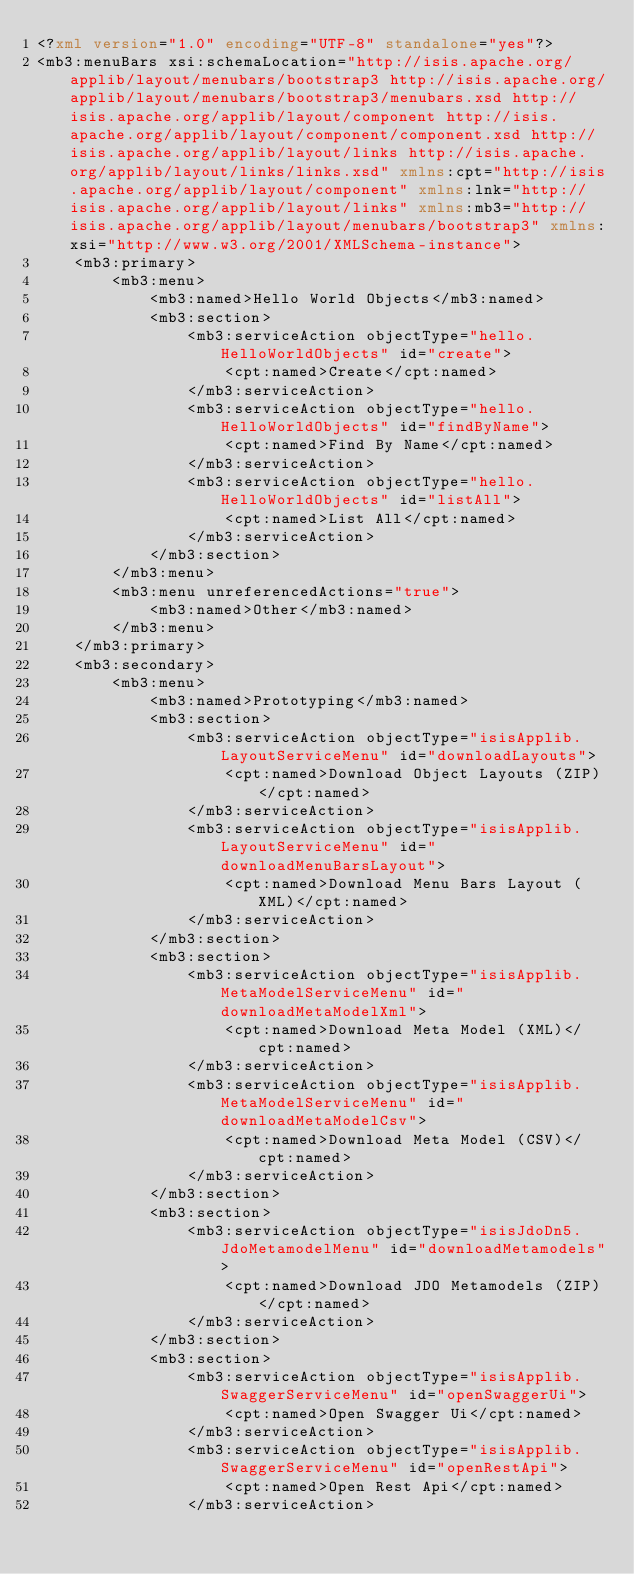<code> <loc_0><loc_0><loc_500><loc_500><_XML_><?xml version="1.0" encoding="UTF-8" standalone="yes"?>
<mb3:menuBars xsi:schemaLocation="http://isis.apache.org/applib/layout/menubars/bootstrap3 http://isis.apache.org/applib/layout/menubars/bootstrap3/menubars.xsd http://isis.apache.org/applib/layout/component http://isis.apache.org/applib/layout/component/component.xsd http://isis.apache.org/applib/layout/links http://isis.apache.org/applib/layout/links/links.xsd" xmlns:cpt="http://isis.apache.org/applib/layout/component" xmlns:lnk="http://isis.apache.org/applib/layout/links" xmlns:mb3="http://isis.apache.org/applib/layout/menubars/bootstrap3" xmlns:xsi="http://www.w3.org/2001/XMLSchema-instance">
    <mb3:primary>
        <mb3:menu>
            <mb3:named>Hello World Objects</mb3:named>
            <mb3:section>
                <mb3:serviceAction objectType="hello.HelloWorldObjects" id="create">
                    <cpt:named>Create</cpt:named>
                </mb3:serviceAction>
                <mb3:serviceAction objectType="hello.HelloWorldObjects" id="findByName">
                    <cpt:named>Find By Name</cpt:named>
                </mb3:serviceAction>
                <mb3:serviceAction objectType="hello.HelloWorldObjects" id="listAll">
                    <cpt:named>List All</cpt:named>
                </mb3:serviceAction>
            </mb3:section>
        </mb3:menu>
        <mb3:menu unreferencedActions="true">
            <mb3:named>Other</mb3:named>
        </mb3:menu>
    </mb3:primary>
    <mb3:secondary>
        <mb3:menu>
            <mb3:named>Prototyping</mb3:named>
            <mb3:section>
                <mb3:serviceAction objectType="isisApplib.LayoutServiceMenu" id="downloadLayouts">
                    <cpt:named>Download Object Layouts (ZIP)</cpt:named>
                </mb3:serviceAction>
                <mb3:serviceAction objectType="isisApplib.LayoutServiceMenu" id="downloadMenuBarsLayout">
                    <cpt:named>Download Menu Bars Layout (XML)</cpt:named>
                </mb3:serviceAction>
            </mb3:section>
            <mb3:section>
                <mb3:serviceAction objectType="isisApplib.MetaModelServiceMenu" id="downloadMetaModelXml">
                    <cpt:named>Download Meta Model (XML)</cpt:named>
                </mb3:serviceAction>
                <mb3:serviceAction objectType="isisApplib.MetaModelServiceMenu" id="downloadMetaModelCsv">
                    <cpt:named>Download Meta Model (CSV)</cpt:named>
                </mb3:serviceAction>
            </mb3:section>
            <mb3:section>
                <mb3:serviceAction objectType="isisJdoDn5.JdoMetamodelMenu" id="downloadMetamodels">
                    <cpt:named>Download JDO Metamodels (ZIP)</cpt:named>
                </mb3:serviceAction>
            </mb3:section>
            <mb3:section>
                <mb3:serviceAction objectType="isisApplib.SwaggerServiceMenu" id="openSwaggerUi">
                    <cpt:named>Open Swagger Ui</cpt:named>
                </mb3:serviceAction>
                <mb3:serviceAction objectType="isisApplib.SwaggerServiceMenu" id="openRestApi">
                    <cpt:named>Open Rest Api</cpt:named>
                </mb3:serviceAction></code> 